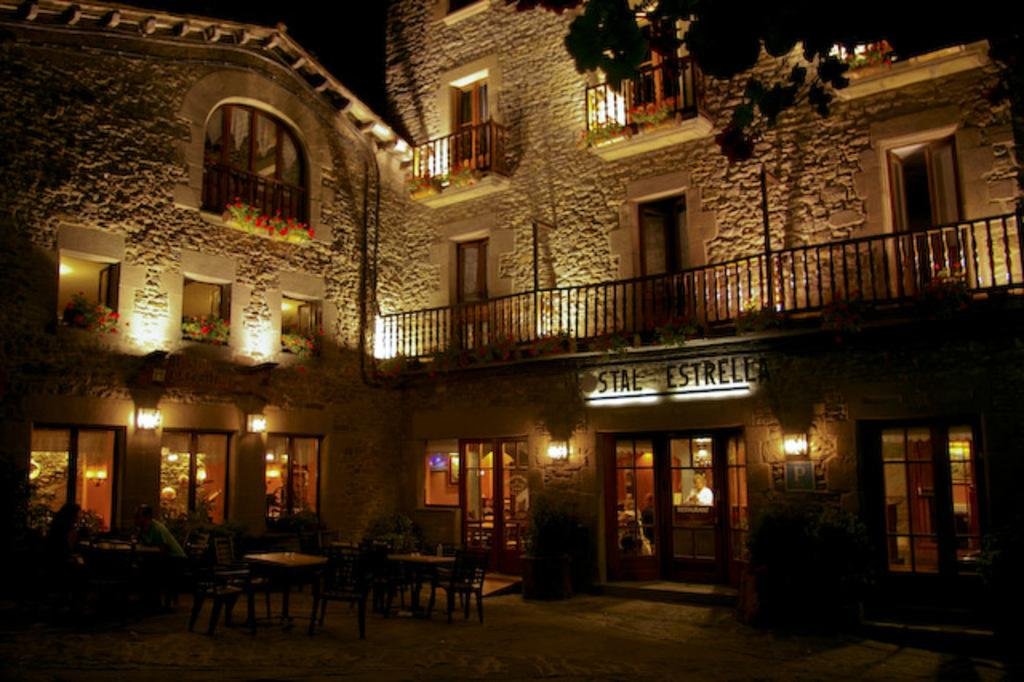What type of structure is visible in the image? There is a building in the image. What feature can be seen on the building? The building has windows. What type of vegetation is present in the image? There are plants, flowers, and a tree in the image. What type of illumination is visible in the image? There are lights in the image. Can you describe the interior of the building? There is a person inside the building, along with tables and chairs. What type of face can be seen on the pail in the image? There is no pail present in the image, and therefore no face can be seen on it. Is the person's mom visible in the image? The provided facts do not mention the person's mom, so it cannot be determined if she is visible in the image. 